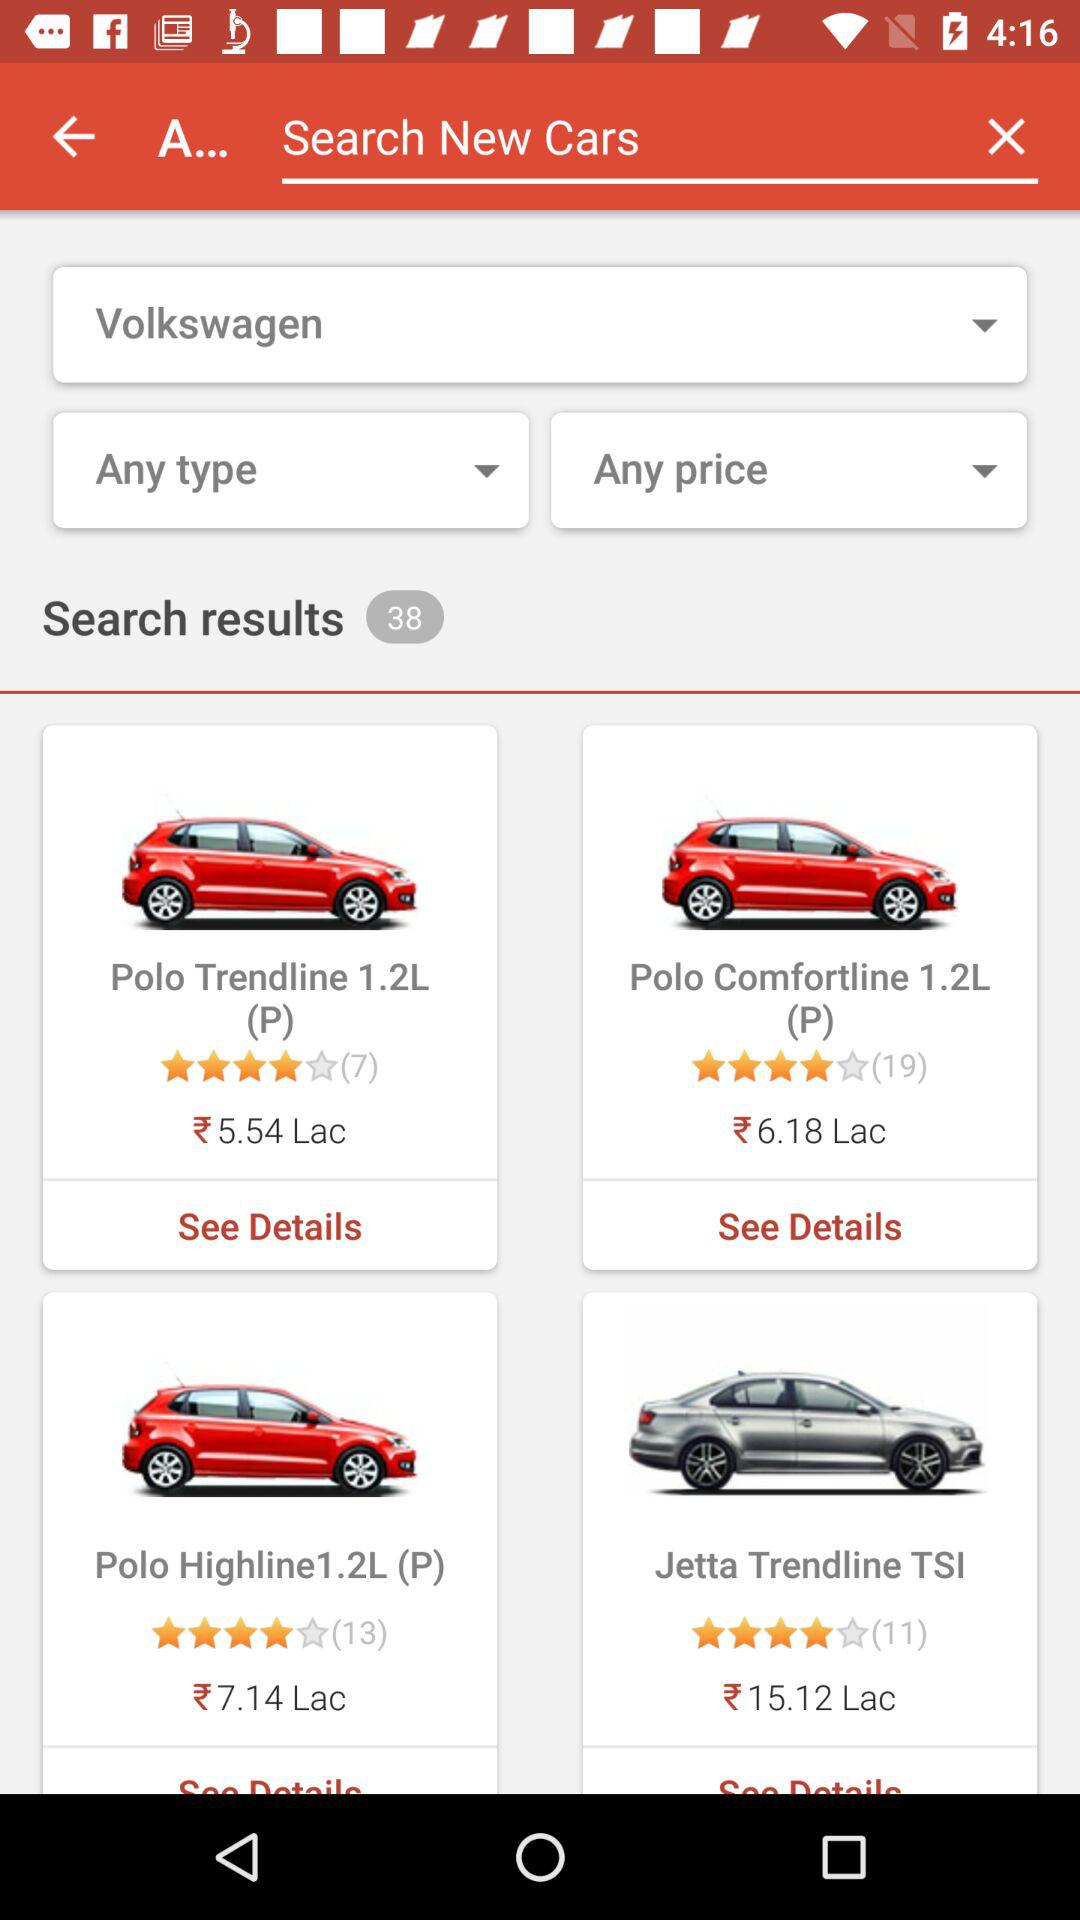How many ratings does "Jetta Trendline TSI" have? The rating is 4 stars. 